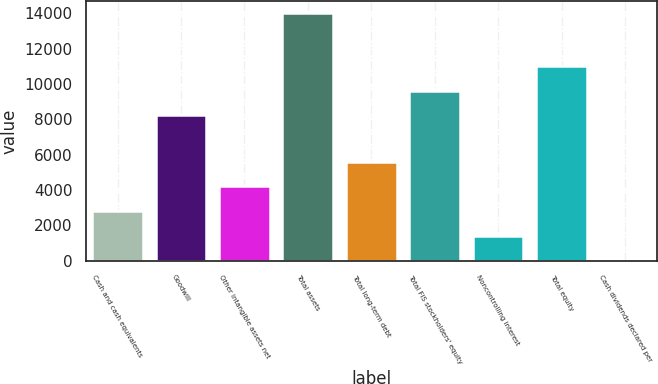<chart> <loc_0><loc_0><loc_500><loc_500><bar_chart><fcel>Cash and cash equivalents<fcel>Goodwill<fcel>Other intangible assets net<fcel>Total assets<fcel>Total long-term debt<fcel>Total FIS stockholders' equity<fcel>Noncontrolling interest<fcel>Total equity<fcel>Cash dividends declared per<nl><fcel>2799.68<fcel>8232.9<fcel>4199.42<fcel>13997.6<fcel>5599.16<fcel>9632.64<fcel>1399.94<fcel>11032.4<fcel>0.2<nl></chart> 